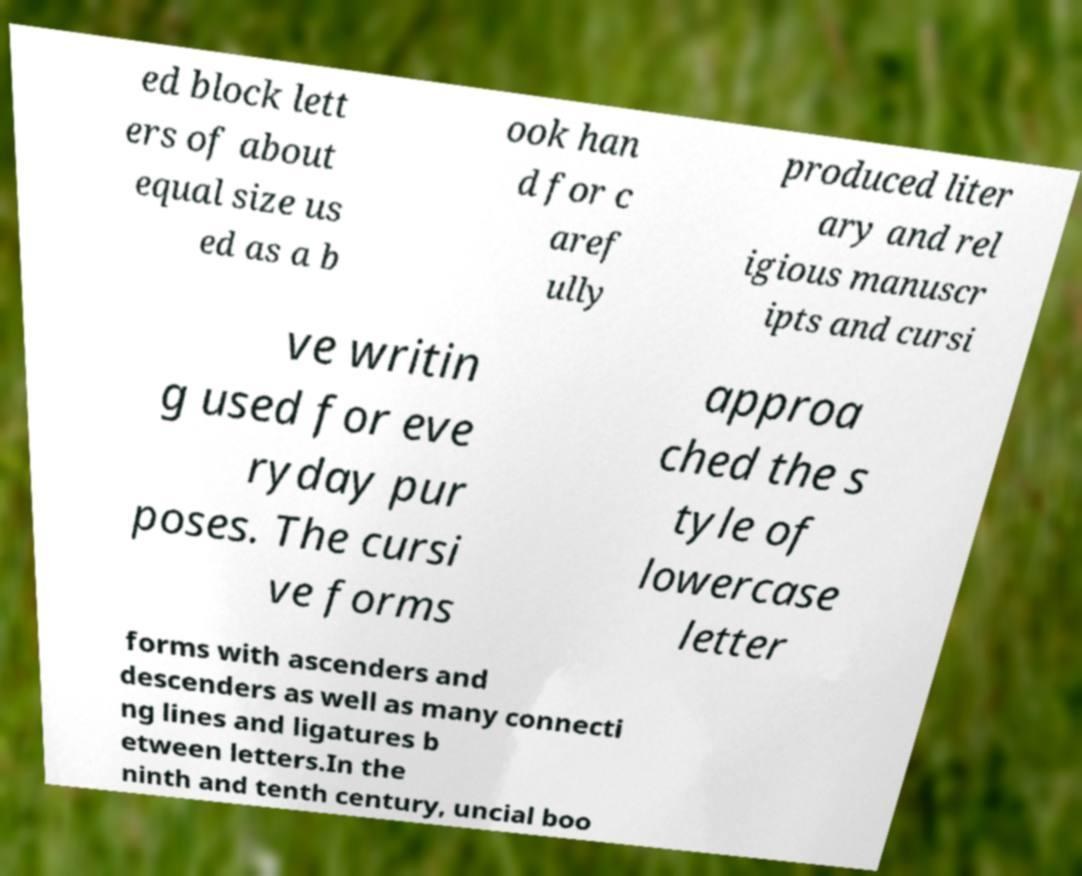What messages or text are displayed in this image? I need them in a readable, typed format. ed block lett ers of about equal size us ed as a b ook han d for c aref ully produced liter ary and rel igious manuscr ipts and cursi ve writin g used for eve ryday pur poses. The cursi ve forms approa ched the s tyle of lowercase letter forms with ascenders and descenders as well as many connecti ng lines and ligatures b etween letters.In the ninth and tenth century, uncial boo 